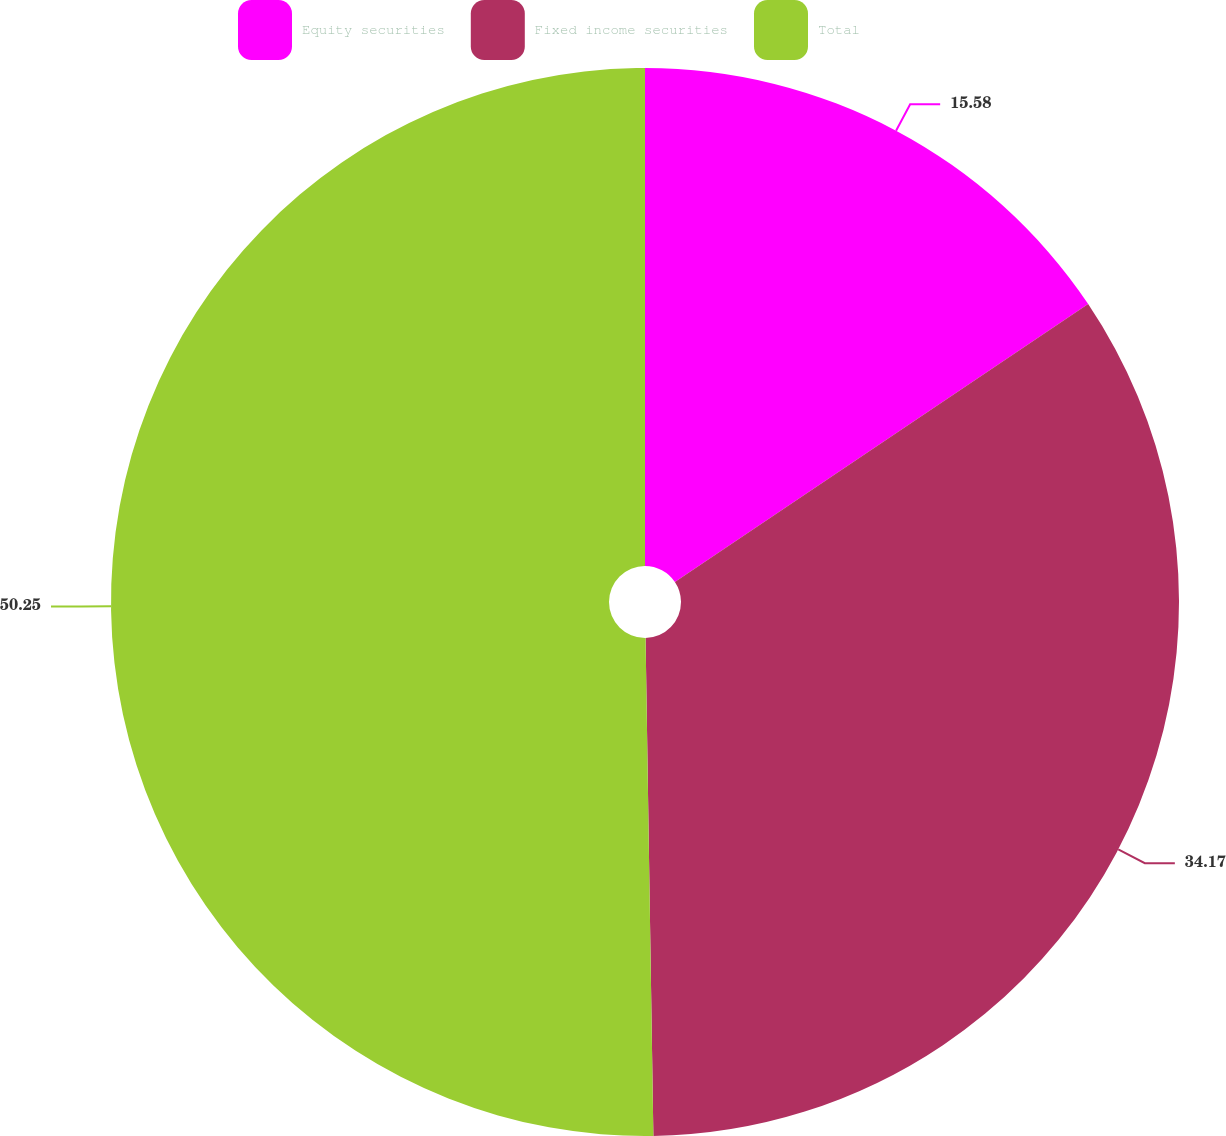<chart> <loc_0><loc_0><loc_500><loc_500><pie_chart><fcel>Equity securities<fcel>Fixed income securities<fcel>Total<nl><fcel>15.58%<fcel>34.17%<fcel>50.25%<nl></chart> 